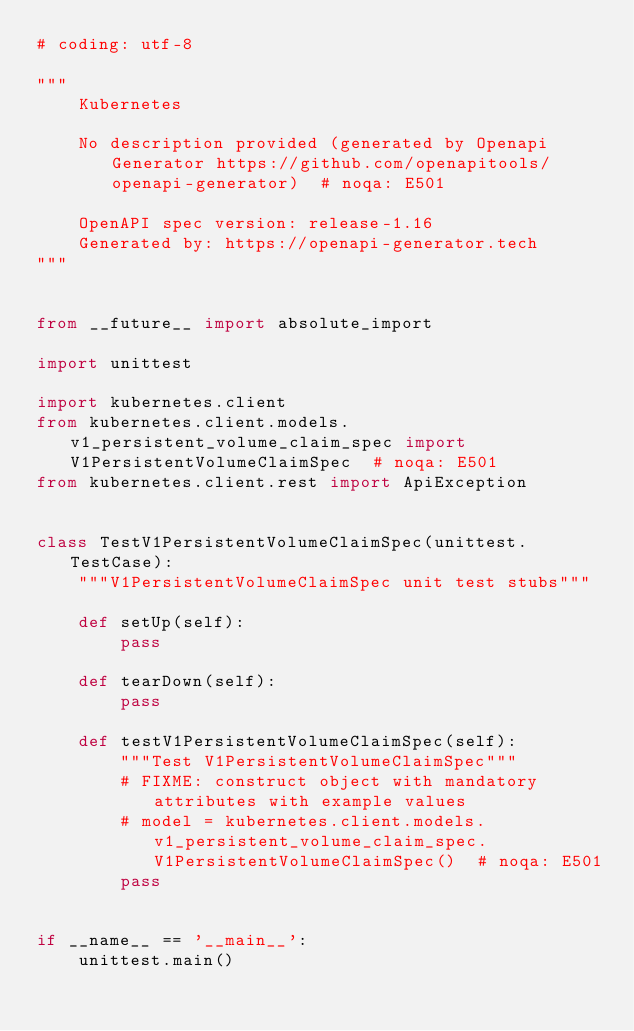<code> <loc_0><loc_0><loc_500><loc_500><_Python_># coding: utf-8

"""
    Kubernetes

    No description provided (generated by Openapi Generator https://github.com/openapitools/openapi-generator)  # noqa: E501

    OpenAPI spec version: release-1.16
    Generated by: https://openapi-generator.tech
"""


from __future__ import absolute_import

import unittest

import kubernetes.client
from kubernetes.client.models.v1_persistent_volume_claim_spec import V1PersistentVolumeClaimSpec  # noqa: E501
from kubernetes.client.rest import ApiException


class TestV1PersistentVolumeClaimSpec(unittest.TestCase):
    """V1PersistentVolumeClaimSpec unit test stubs"""

    def setUp(self):
        pass

    def tearDown(self):
        pass

    def testV1PersistentVolumeClaimSpec(self):
        """Test V1PersistentVolumeClaimSpec"""
        # FIXME: construct object with mandatory attributes with example values
        # model = kubernetes.client.models.v1_persistent_volume_claim_spec.V1PersistentVolumeClaimSpec()  # noqa: E501
        pass


if __name__ == '__main__':
    unittest.main()
</code> 